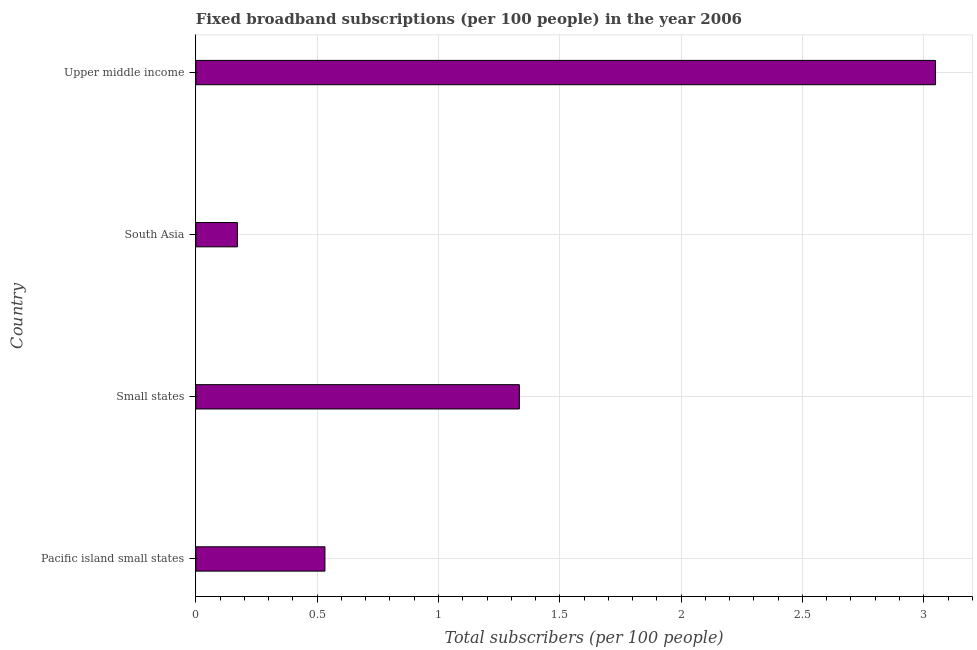Does the graph contain any zero values?
Your answer should be very brief. No. What is the title of the graph?
Give a very brief answer. Fixed broadband subscriptions (per 100 people) in the year 2006. What is the label or title of the X-axis?
Make the answer very short. Total subscribers (per 100 people). What is the total number of fixed broadband subscriptions in South Asia?
Provide a succinct answer. 0.17. Across all countries, what is the maximum total number of fixed broadband subscriptions?
Give a very brief answer. 3.05. Across all countries, what is the minimum total number of fixed broadband subscriptions?
Make the answer very short. 0.17. In which country was the total number of fixed broadband subscriptions maximum?
Provide a succinct answer. Upper middle income. What is the sum of the total number of fixed broadband subscriptions?
Ensure brevity in your answer.  5.09. What is the difference between the total number of fixed broadband subscriptions in South Asia and Upper middle income?
Give a very brief answer. -2.88. What is the average total number of fixed broadband subscriptions per country?
Provide a succinct answer. 1.27. What is the median total number of fixed broadband subscriptions?
Provide a short and direct response. 0.93. In how many countries, is the total number of fixed broadband subscriptions greater than 2.8 ?
Keep it short and to the point. 1. What is the ratio of the total number of fixed broadband subscriptions in Small states to that in South Asia?
Keep it short and to the point. 7.78. Is the difference between the total number of fixed broadband subscriptions in South Asia and Upper middle income greater than the difference between any two countries?
Your answer should be very brief. Yes. What is the difference between the highest and the second highest total number of fixed broadband subscriptions?
Provide a succinct answer. 1.72. Is the sum of the total number of fixed broadband subscriptions in Pacific island small states and Upper middle income greater than the maximum total number of fixed broadband subscriptions across all countries?
Make the answer very short. Yes. What is the difference between the highest and the lowest total number of fixed broadband subscriptions?
Your answer should be compact. 2.88. Are all the bars in the graph horizontal?
Your answer should be compact. Yes. How many countries are there in the graph?
Your response must be concise. 4. What is the Total subscribers (per 100 people) of Pacific island small states?
Give a very brief answer. 0.53. What is the Total subscribers (per 100 people) in Small states?
Keep it short and to the point. 1.33. What is the Total subscribers (per 100 people) in South Asia?
Provide a short and direct response. 0.17. What is the Total subscribers (per 100 people) in Upper middle income?
Your answer should be compact. 3.05. What is the difference between the Total subscribers (per 100 people) in Pacific island small states and Small states?
Your answer should be compact. -0.8. What is the difference between the Total subscribers (per 100 people) in Pacific island small states and South Asia?
Your answer should be very brief. 0.36. What is the difference between the Total subscribers (per 100 people) in Pacific island small states and Upper middle income?
Your answer should be compact. -2.52. What is the difference between the Total subscribers (per 100 people) in Small states and South Asia?
Your answer should be compact. 1.16. What is the difference between the Total subscribers (per 100 people) in Small states and Upper middle income?
Keep it short and to the point. -1.72. What is the difference between the Total subscribers (per 100 people) in South Asia and Upper middle income?
Provide a short and direct response. -2.88. What is the ratio of the Total subscribers (per 100 people) in Pacific island small states to that in Small states?
Provide a short and direct response. 0.4. What is the ratio of the Total subscribers (per 100 people) in Pacific island small states to that in South Asia?
Your answer should be compact. 3.11. What is the ratio of the Total subscribers (per 100 people) in Pacific island small states to that in Upper middle income?
Offer a very short reply. 0.17. What is the ratio of the Total subscribers (per 100 people) in Small states to that in South Asia?
Your answer should be very brief. 7.78. What is the ratio of the Total subscribers (per 100 people) in Small states to that in Upper middle income?
Your answer should be compact. 0.44. What is the ratio of the Total subscribers (per 100 people) in South Asia to that in Upper middle income?
Ensure brevity in your answer.  0.06. 